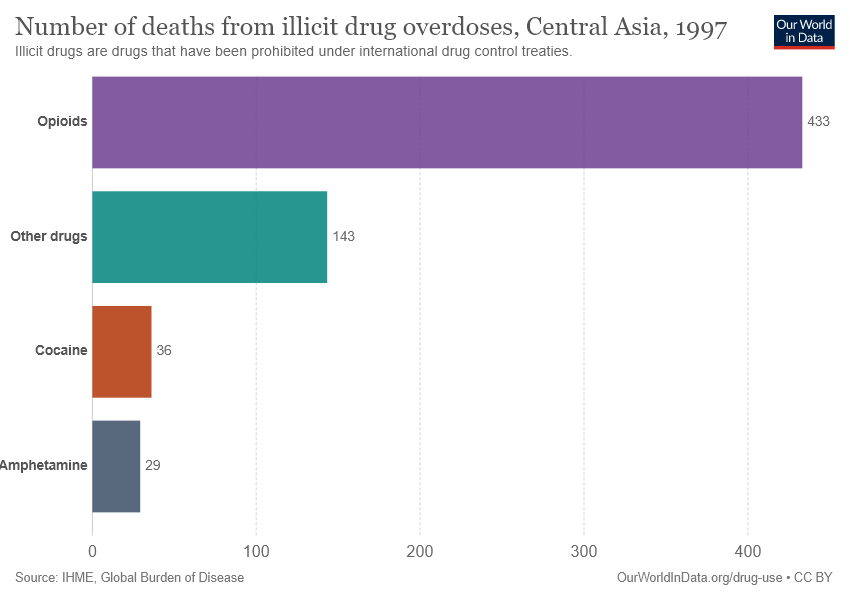Highlight a few significant elements in this photo. The value of Cocaine and Amphetamine drugs is significantly different. The drugs that show the value of 433 death cases are opioids. 